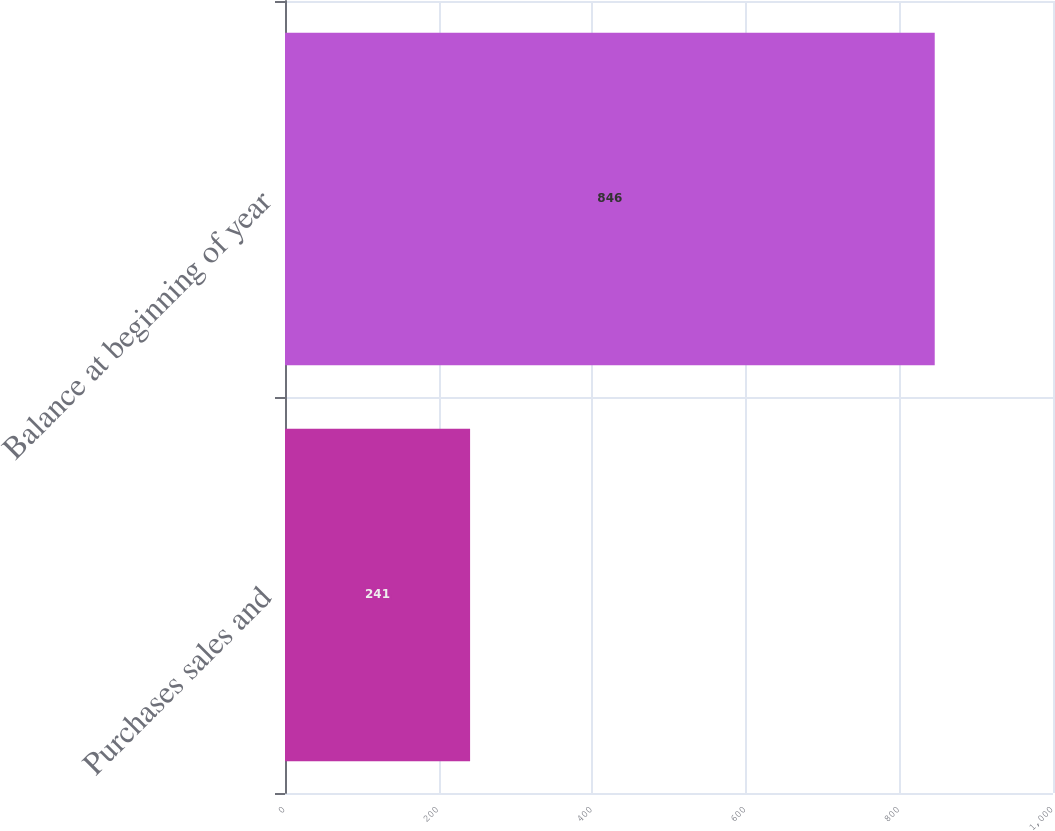Convert chart to OTSL. <chart><loc_0><loc_0><loc_500><loc_500><bar_chart><fcel>Purchases sales and<fcel>Balance at beginning of year<nl><fcel>241<fcel>846<nl></chart> 